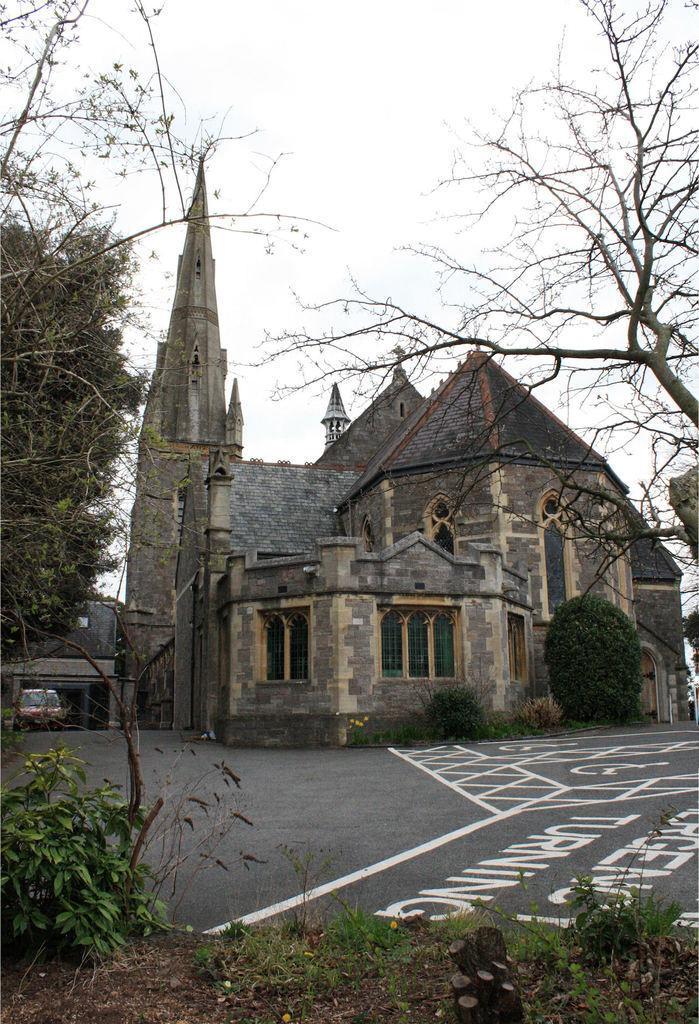What is the main structure in the middle of the image? There is a house in the middle of the image. What else can be seen in the image besides the house? There is a road in the image. What type of vegetation is on the left side of the image? There are trees on the left side of the image. What type of cast can be seen on the house in the image? There is no cast present on the house in the image. What is the pail used for in the image? There is no pail present in the image. 